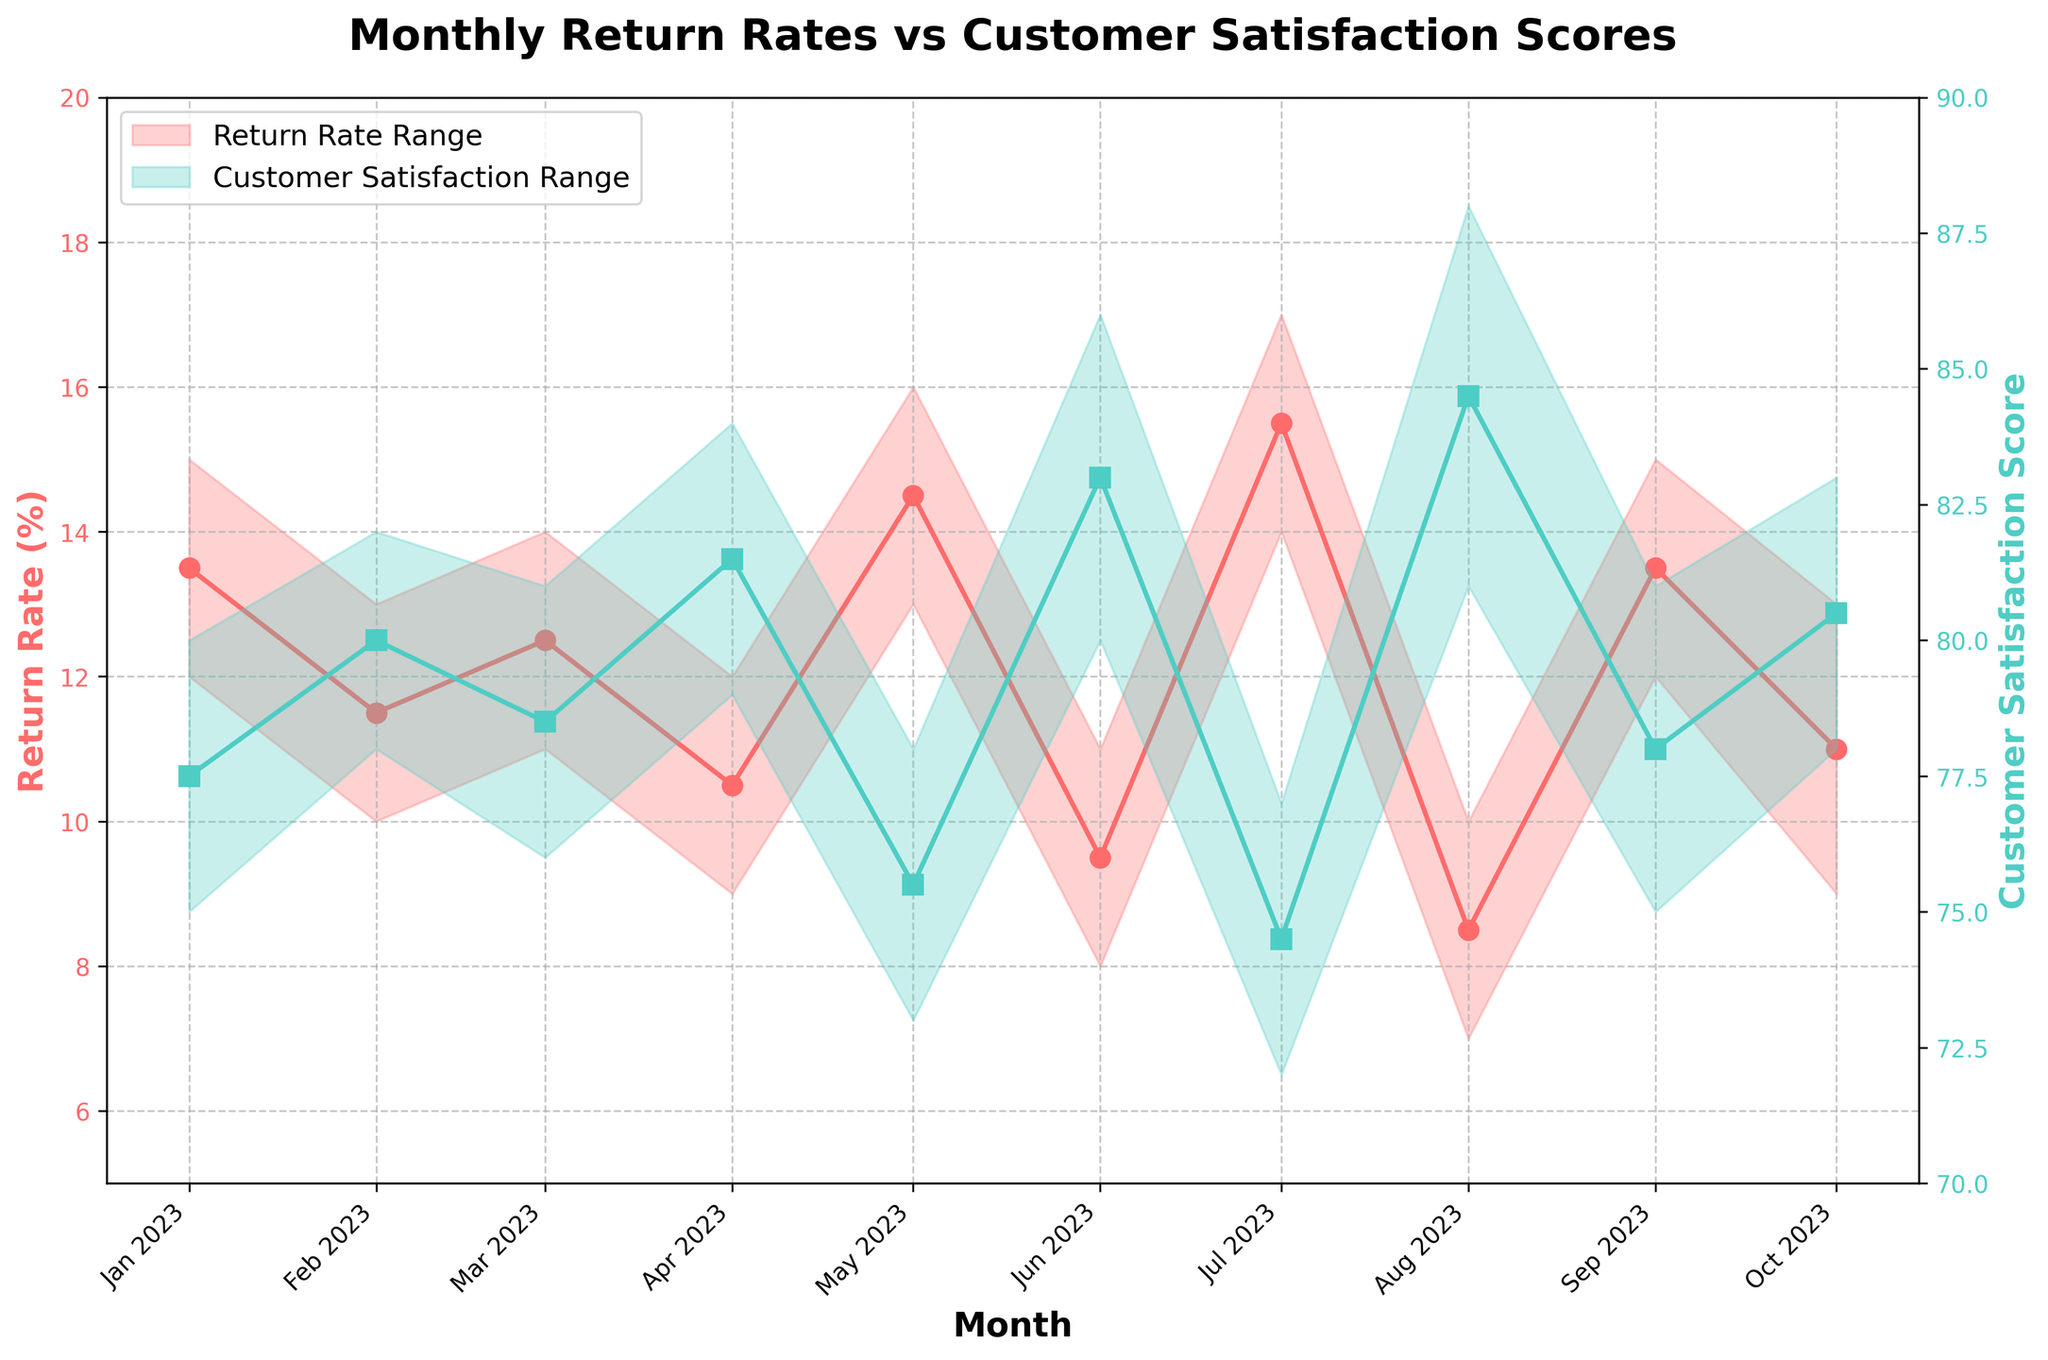What's the title of the chart? The title of the chart is given at the top center of the figure in bold, large font.
Answer: Monthly Return Rates vs Customer Satisfaction Scores What is the range of return rates in July 2023? In the plot, the range for return rates in July 2023 is indicated by the filled area between the two lines for that month. The minimum value is 14% and the maximum value is 17%.
Answer: 14% to 17% Which month had the highest minimum customer satisfaction score? The filled area for customer satisfaction scores reaches its highest minimum value in August 2023. The minimum score for that month is 81.
Answer: August 2023 Does the return rate increase or decrease from April 2023 to May 2023? By observing the lines representing the return rate in April and May 2023, we can see that the rates increase from a range of 9-12% to 13-16%.
Answer: Increase What is the average return rate for February 2023? To find the average return rate for February 2023, add the minimum and maximum values and divide by 2. For February: (10% + 13%) / 2 = 11.5%.
Answer: 11.5% When did the customer satisfaction score reach its highest maximum value? The plot shows the highest maximum customer satisfaction score in August 2023, reaching a value of 88.
Answer: August 2023 Which month shows the largest range in customer satisfaction scores? The range for the customer satisfaction scores is the widest in June 2023, going from 80 to 86. The range is 6.
Answer: June 2023 Compare the return rates from January 2023 to October 2023. Do they generally increase, decrease, or fluctuate? Looking at the trend for return rates from January to October 2023, they generally fluctuate. They decrease from January to April, increase again in May and July, then show another decrease in October.
Answer: Fluctuate How does the return rate range in August 2023 compare to that in October 2023? The return rate range for August 2023 (7-10%) is narrower and lower than the range in October 2023 (9-13%).
Answer: Narrower and lower In which month is the gap between return rate and customer satisfaction score the smallest? By examining the differences between return rate and customer satisfaction score ranges from month to month, the smallest gap is in August 2023 where the return rate is 7-10% and customer satisfaction is 81-88%.
Answer: August 2023 